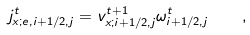Convert formula to latex. <formula><loc_0><loc_0><loc_500><loc_500>j _ { x ; e , i + 1 / 2 , j } ^ { t } = v _ { x ; i + 1 / 2 , j } ^ { t + 1 } \omega _ { i + 1 / 2 , j } ^ { t } \quad ,</formula> 